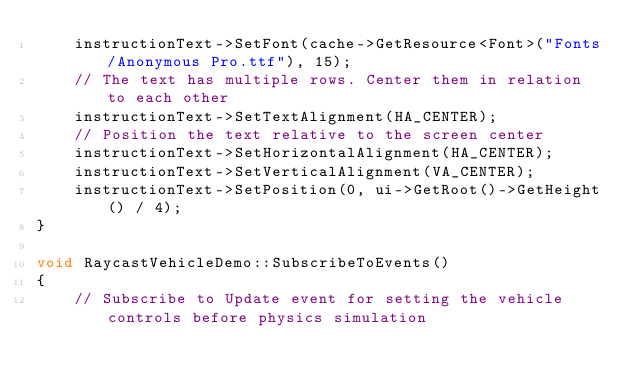<code> <loc_0><loc_0><loc_500><loc_500><_C++_>    instructionText->SetFont(cache->GetResource<Font>("Fonts/Anonymous Pro.ttf"), 15);
    // The text has multiple rows. Center them in relation to each other
    instructionText->SetTextAlignment(HA_CENTER);
    // Position the text relative to the screen center
    instructionText->SetHorizontalAlignment(HA_CENTER);
    instructionText->SetVerticalAlignment(VA_CENTER);
    instructionText->SetPosition(0, ui->GetRoot()->GetHeight() / 4);
}

void RaycastVehicleDemo::SubscribeToEvents()
{
    // Subscribe to Update event for setting the vehicle controls before physics simulation</code> 